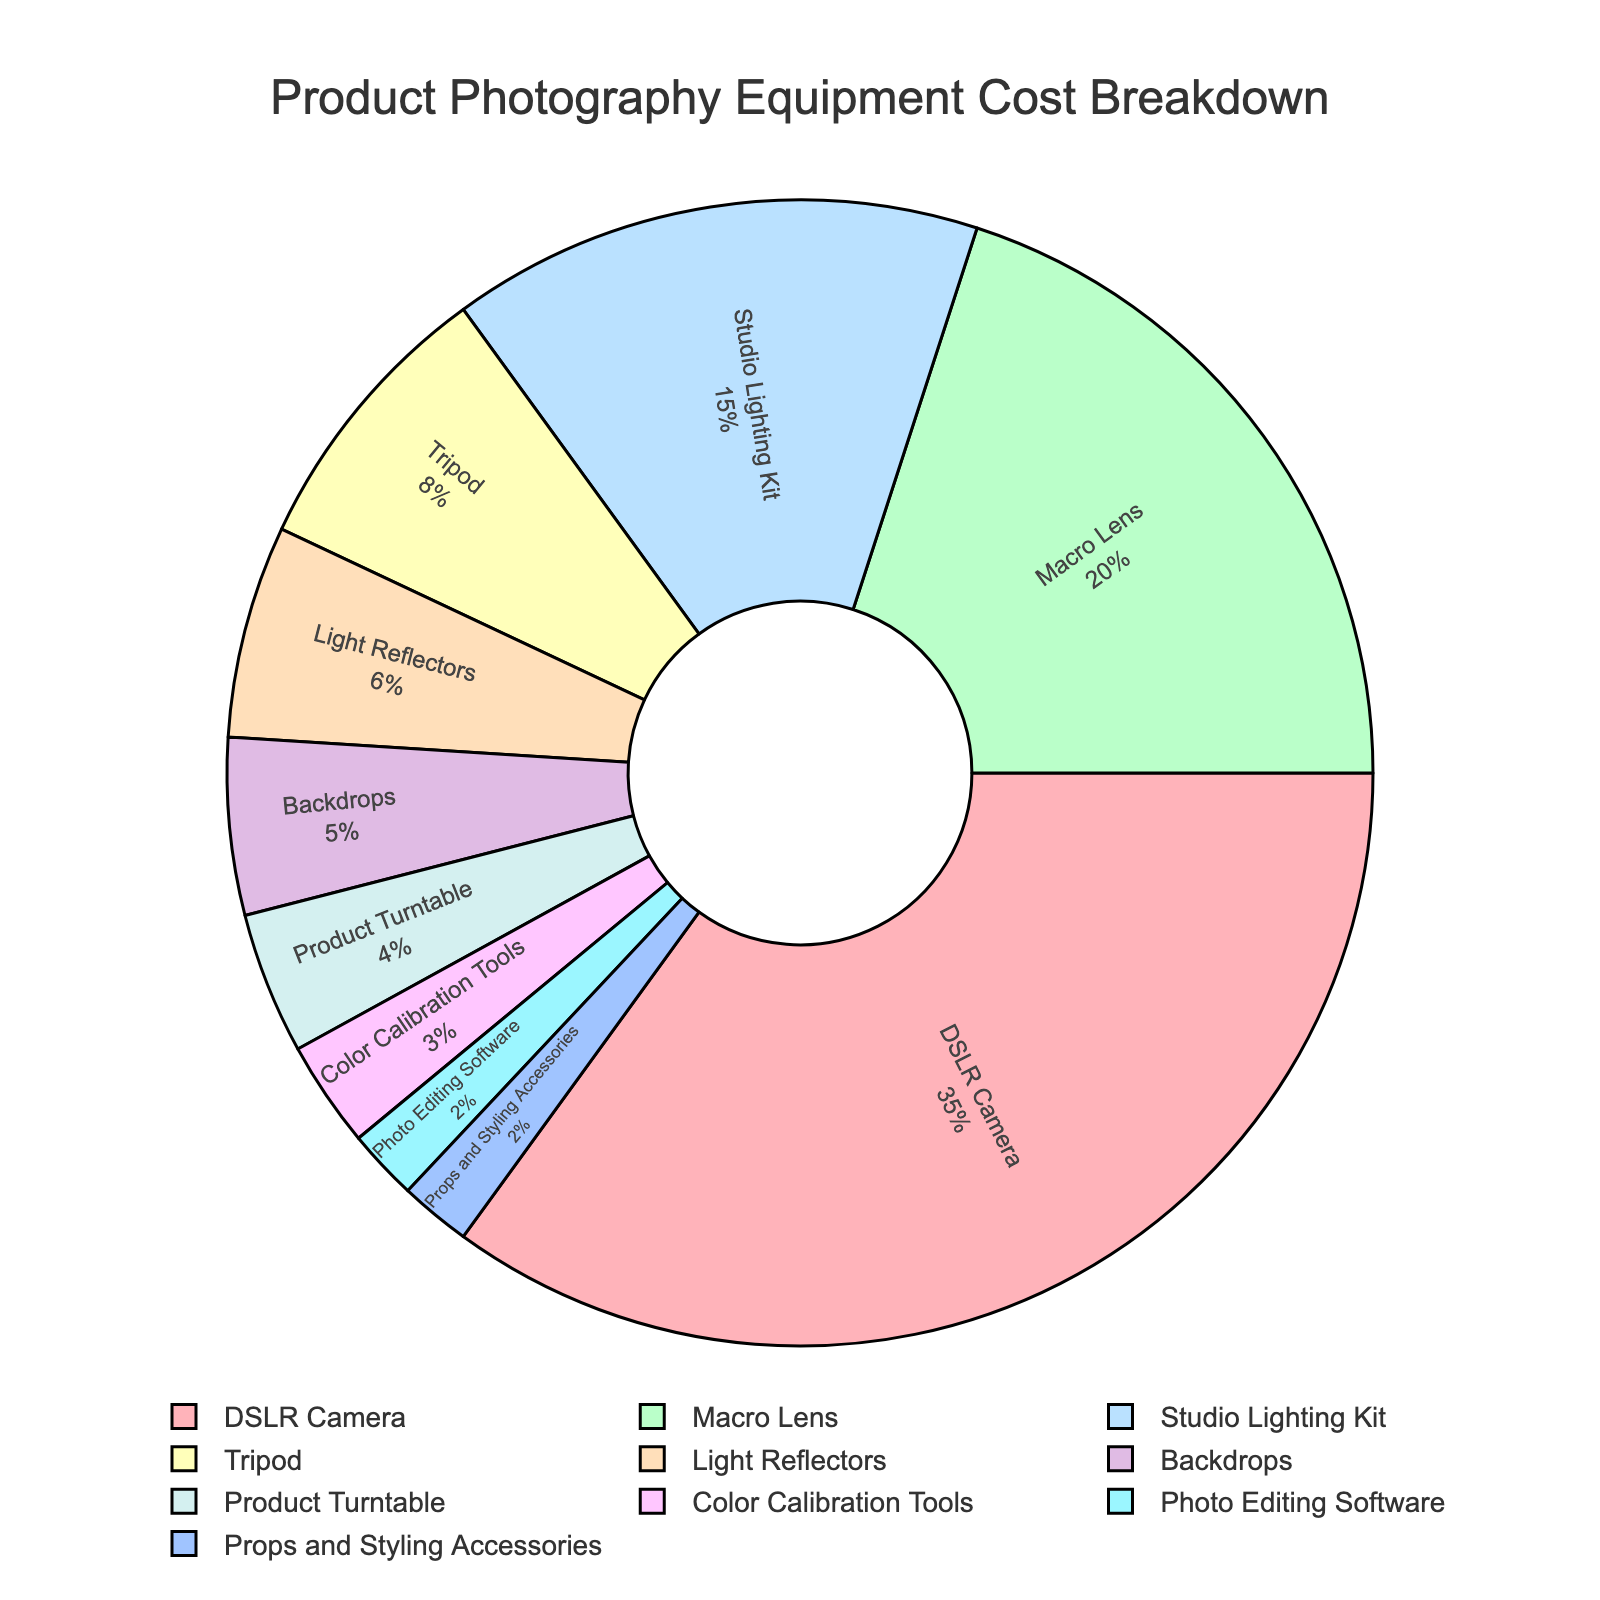What is the largest portion of the photography equipment cost? The largest portion can be identified by the largest segment in the pie chart and the corresponding label. The segment labeled "DSLR Camera" is the largest, occupying 35% of the chart.
Answer: DSLR Camera What is the combined cost percentage of the Macro Lens and the Studio Lighting Kit? To find the combined percentage, look at the values next to Macro Lens (20%) and Studio Lighting Kit (15%) and add them together: 20% + 15% = 35%.
Answer: 35% Which equipment costs more, Tripod or Backdrops? Comparing the size of the segments, the Tripod segment is larger than the Backdrops segment. The Tripod is 8%, and the Backdrops is 5%. Thus, the Tripod costs more.
Answer: Tripod How much more is spent on the DSLR Camera compared to the Macro Lens? The DSLR Camera contributes 35%, and the Macro Lens contributes 20%. Subtract the Macro Lens percentage from the DSLR Camera percentage: 35% - 20% = 15%.
Answer: 15% What is the total cost percentage of equipment costing less than 10% each? Identify all equipment costing less than 10% and sum their percentages: Tripod (8%) + Light Reflectors (6%) + Backdrops (5%) + Product Turntable (4%) + Color Calibration Tools (3%) + Photo Editing Software (2%) + Props and Styling Accessories (2%). The total is 8% + 6% + 5% + 4% + 3% + 2% + 2% = 30%.
Answer: 30% Which two pieces of equipment together make up exactly 8% of the cost? Look for two segments whose percentages add up to 8%. Props and Styling Accessories (2%) and Photo Editing Software (2%) together sum to 4%, not 8%. The segments do not match. Trying Backdrops (5%) and Color Calibration Tools (3%), they sum to 8%.
Answer: Backdrops and Color Calibration Tools What is the smallest portion of the photography equipment cost? The smallest portion can be identified by the smallest segment in the pie chart and its corresponding label. The segments labeled "Photo Editing Software" and "Props and Styling Accessories" are the smallest, each occupying 2% of the chart.
Answer: Photo Editing Software or Props and Styling Accessories How does the cost of studio lighting compare to the combined cost of tripods and light reflectors? The cost of the Studio Lighting Kit is 15%. The combined cost of Tripods (8%) and Light Reflectors (6%) is 8% + 6% = 14%. The Studio Lighting Kit is 1% more than the combined cost of Tripods and Light Reflectors.
Answer: Studio Lighting Kit is 1% more What is the cost difference between the Product Turntable and Color Calibration Tools? The Product Turntable contributes 4%, and the Color Calibration Tools contribute 3%. Subtract the Color Calibration Tools percentage from the Product Turntable percentage: 4% - 3% = 1%.
Answer: 1% 